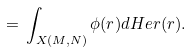Convert formula to latex. <formula><loc_0><loc_0><loc_500><loc_500>\, = \, \int _ { X ( M , N ) } \phi ( r ) d H e r ( r ) .</formula> 